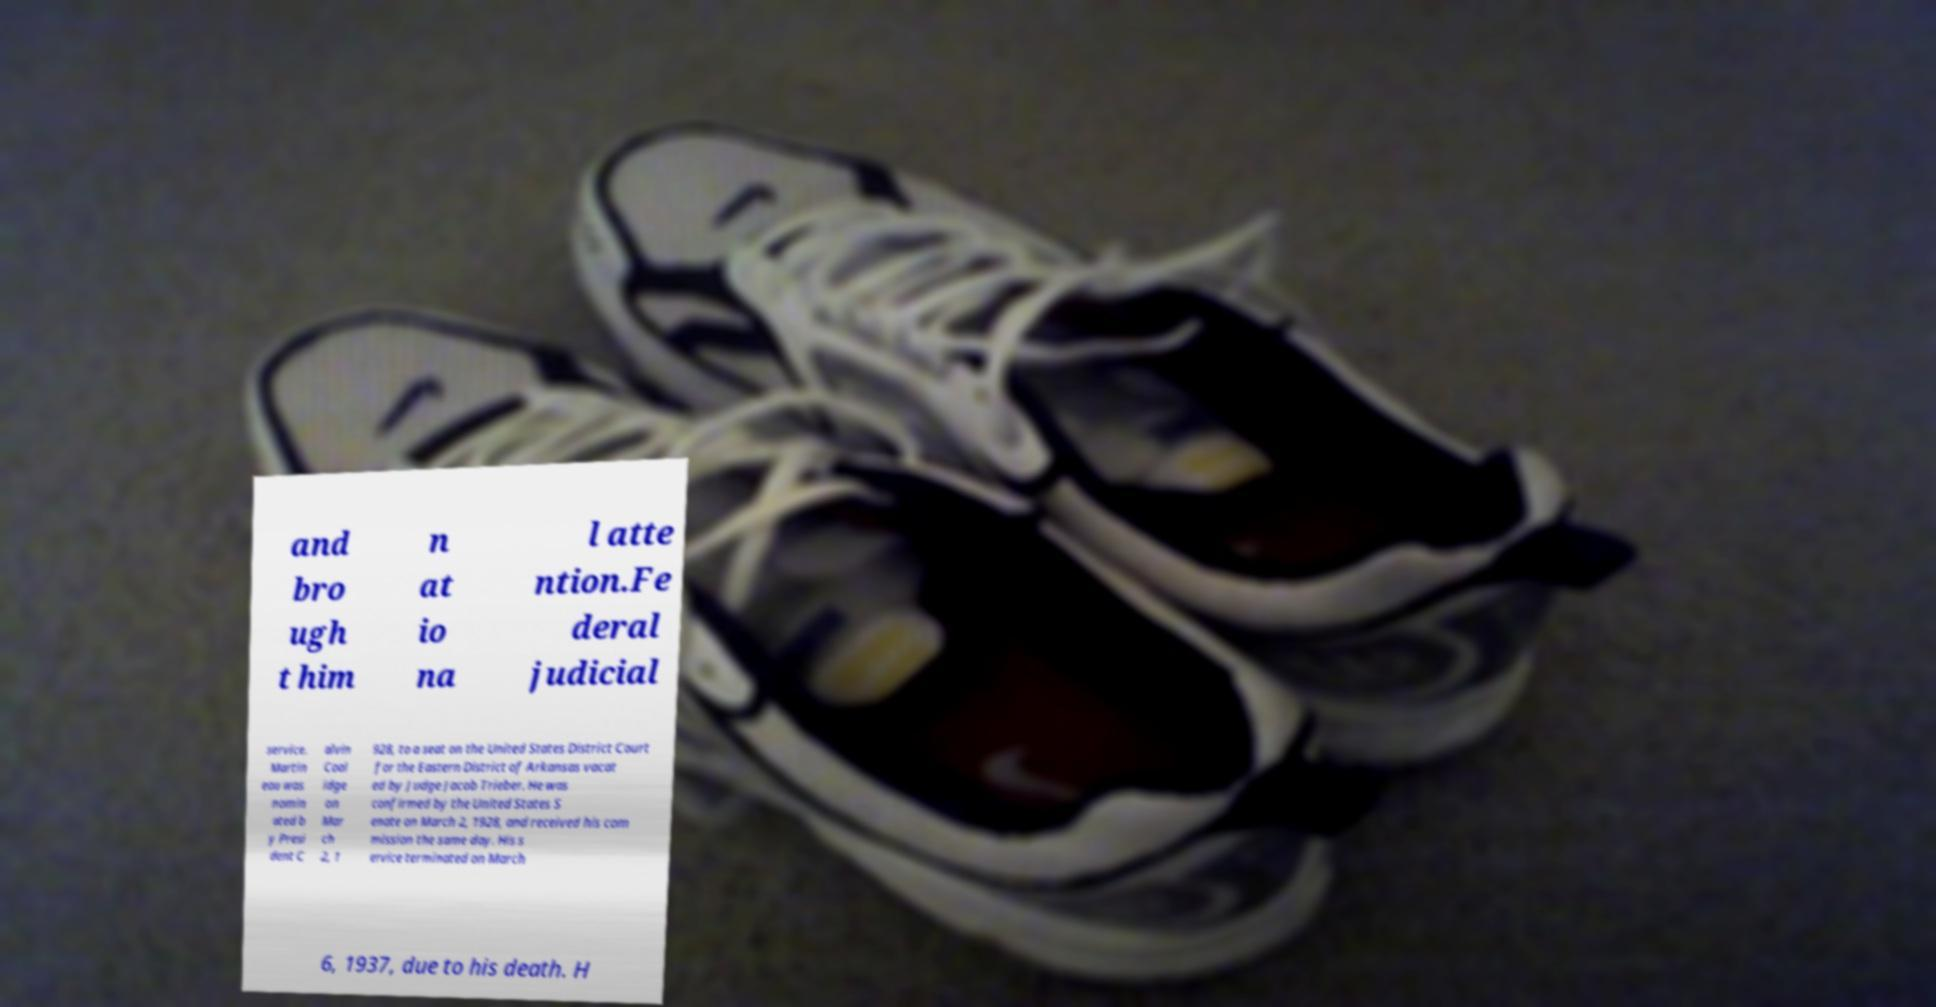Can you read and provide the text displayed in the image?This photo seems to have some interesting text. Can you extract and type it out for me? and bro ugh t him n at io na l atte ntion.Fe deral judicial service. Martin eau was nomin ated b y Presi dent C alvin Cool idge on Mar ch 2, 1 928, to a seat on the United States District Court for the Eastern District of Arkansas vacat ed by Judge Jacob Trieber. He was confirmed by the United States S enate on March 2, 1928, and received his com mission the same day. His s ervice terminated on March 6, 1937, due to his death. H 